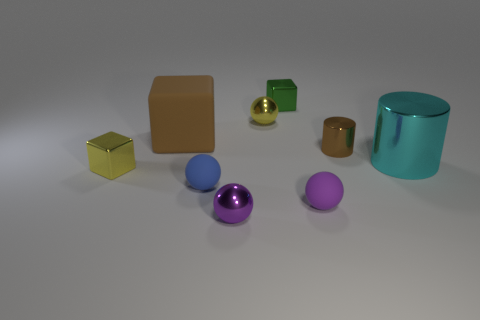Are there more big objects in front of the big brown rubber block than yellow metallic things that are right of the small brown metal thing?
Keep it short and to the point. Yes. How many other small objects have the same material as the cyan thing?
Provide a succinct answer. 5. There is a yellow shiny object in front of the brown matte cube; is it the same shape as the matte object that is behind the big cylinder?
Provide a short and direct response. Yes. There is a big thing right of the small blue rubber thing; what is its color?
Your answer should be very brief. Cyan. Are there any blue rubber objects of the same shape as the cyan object?
Your answer should be very brief. No. What is the cyan thing made of?
Make the answer very short. Metal. There is a block that is both left of the tiny purple metal ball and behind the large cyan metallic cylinder; how big is it?
Provide a succinct answer. Large. What is the material of the cube that is the same color as the small cylinder?
Ensure brevity in your answer.  Rubber. How many small metal things are there?
Provide a succinct answer. 5. Is the number of tiny purple rubber cylinders less than the number of tiny metallic cubes?
Your answer should be very brief. Yes. 